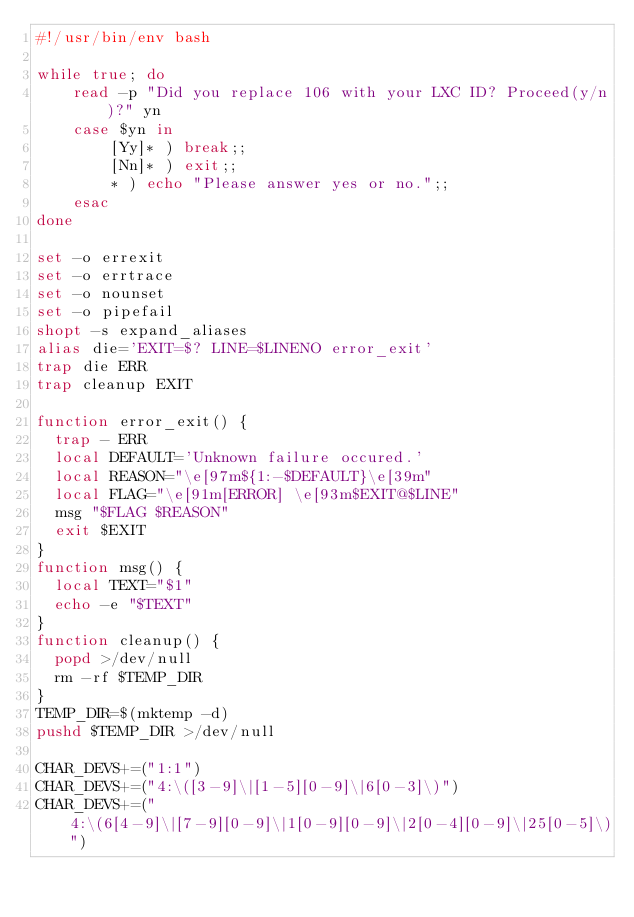<code> <loc_0><loc_0><loc_500><loc_500><_Bash_>#!/usr/bin/env bash

while true; do
    read -p "Did you replace 106 with your LXC ID? Proceed(y/n)?" yn
    case $yn in
        [Yy]* ) break;;
        [Nn]* ) exit;;
        * ) echo "Please answer yes or no.";;
    esac
done

set -o errexit
set -o errtrace
set -o nounset
set -o pipefail
shopt -s expand_aliases
alias die='EXIT=$? LINE=$LINENO error_exit'
trap die ERR
trap cleanup EXIT

function error_exit() {
  trap - ERR
  local DEFAULT='Unknown failure occured.'
  local REASON="\e[97m${1:-$DEFAULT}\e[39m"
  local FLAG="\e[91m[ERROR] \e[93m$EXIT@$LINE"
  msg "$FLAG $REASON"
  exit $EXIT
}
function msg() {
  local TEXT="$1"
  echo -e "$TEXT"
}
function cleanup() {
  popd >/dev/null
  rm -rf $TEMP_DIR
}
TEMP_DIR=$(mktemp -d)
pushd $TEMP_DIR >/dev/null

CHAR_DEVS+=("1:1")
CHAR_DEVS+=("4:\([3-9]\|[1-5][0-9]\|6[0-3]\)")
CHAR_DEVS+=("4:\(6[4-9]\|[7-9][0-9]\|1[0-9][0-9]\|2[0-4][0-9]\|25[0-5]\)")</code> 